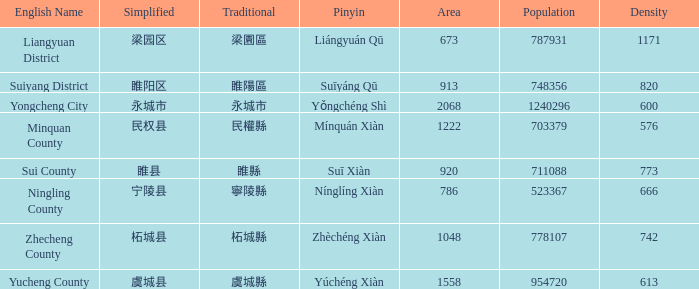What is the number of density figures available for yucheng county? 1.0. 